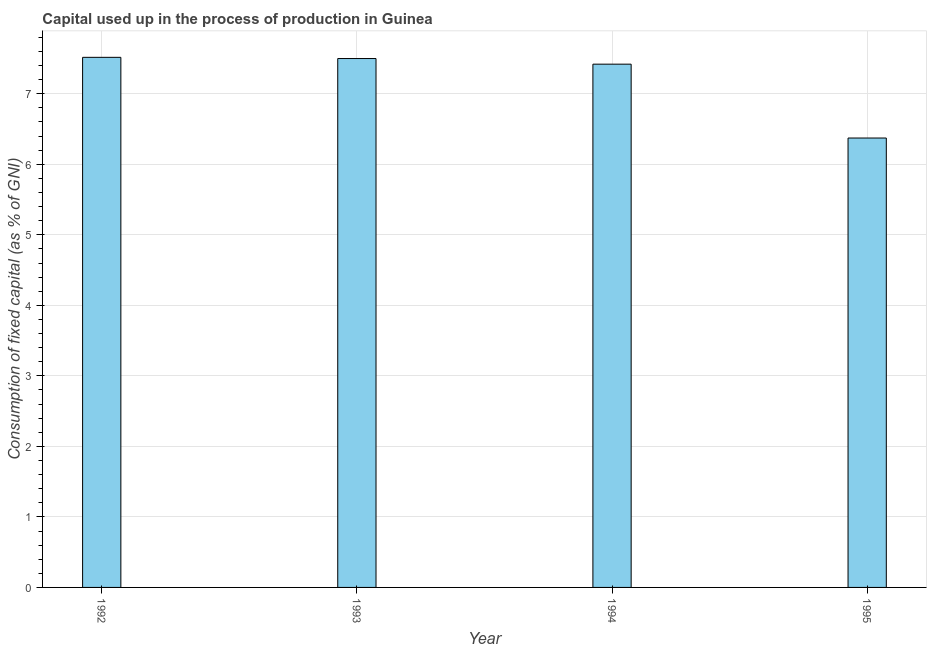Does the graph contain any zero values?
Your answer should be compact. No. Does the graph contain grids?
Offer a very short reply. Yes. What is the title of the graph?
Provide a succinct answer. Capital used up in the process of production in Guinea. What is the label or title of the X-axis?
Your response must be concise. Year. What is the label or title of the Y-axis?
Your response must be concise. Consumption of fixed capital (as % of GNI). What is the consumption of fixed capital in 1994?
Provide a succinct answer. 7.42. Across all years, what is the maximum consumption of fixed capital?
Give a very brief answer. 7.52. Across all years, what is the minimum consumption of fixed capital?
Your answer should be very brief. 6.37. In which year was the consumption of fixed capital maximum?
Your answer should be very brief. 1992. What is the sum of the consumption of fixed capital?
Provide a short and direct response. 28.81. What is the difference between the consumption of fixed capital in 1994 and 1995?
Keep it short and to the point. 1.05. What is the average consumption of fixed capital per year?
Give a very brief answer. 7.2. What is the median consumption of fixed capital?
Provide a short and direct response. 7.46. In how many years, is the consumption of fixed capital greater than 6.2 %?
Your answer should be compact. 4. What is the ratio of the consumption of fixed capital in 1993 to that in 1995?
Keep it short and to the point. 1.18. Is the difference between the consumption of fixed capital in 1992 and 1994 greater than the difference between any two years?
Provide a succinct answer. No. What is the difference between the highest and the second highest consumption of fixed capital?
Make the answer very short. 0.02. What is the difference between the highest and the lowest consumption of fixed capital?
Offer a terse response. 1.14. In how many years, is the consumption of fixed capital greater than the average consumption of fixed capital taken over all years?
Keep it short and to the point. 3. How many bars are there?
Make the answer very short. 4. Are all the bars in the graph horizontal?
Your answer should be very brief. No. How many years are there in the graph?
Keep it short and to the point. 4. Are the values on the major ticks of Y-axis written in scientific E-notation?
Make the answer very short. No. What is the Consumption of fixed capital (as % of GNI) of 1992?
Give a very brief answer. 7.52. What is the Consumption of fixed capital (as % of GNI) of 1993?
Your response must be concise. 7.5. What is the Consumption of fixed capital (as % of GNI) of 1994?
Your response must be concise. 7.42. What is the Consumption of fixed capital (as % of GNI) in 1995?
Provide a succinct answer. 6.37. What is the difference between the Consumption of fixed capital (as % of GNI) in 1992 and 1993?
Ensure brevity in your answer.  0.02. What is the difference between the Consumption of fixed capital (as % of GNI) in 1992 and 1994?
Offer a very short reply. 0.1. What is the difference between the Consumption of fixed capital (as % of GNI) in 1992 and 1995?
Provide a succinct answer. 1.14. What is the difference between the Consumption of fixed capital (as % of GNI) in 1993 and 1994?
Give a very brief answer. 0.08. What is the difference between the Consumption of fixed capital (as % of GNI) in 1993 and 1995?
Make the answer very short. 1.13. What is the difference between the Consumption of fixed capital (as % of GNI) in 1994 and 1995?
Ensure brevity in your answer.  1.05. What is the ratio of the Consumption of fixed capital (as % of GNI) in 1992 to that in 1993?
Keep it short and to the point. 1. What is the ratio of the Consumption of fixed capital (as % of GNI) in 1992 to that in 1994?
Give a very brief answer. 1.01. What is the ratio of the Consumption of fixed capital (as % of GNI) in 1992 to that in 1995?
Give a very brief answer. 1.18. What is the ratio of the Consumption of fixed capital (as % of GNI) in 1993 to that in 1994?
Make the answer very short. 1.01. What is the ratio of the Consumption of fixed capital (as % of GNI) in 1993 to that in 1995?
Make the answer very short. 1.18. What is the ratio of the Consumption of fixed capital (as % of GNI) in 1994 to that in 1995?
Your answer should be compact. 1.16. 